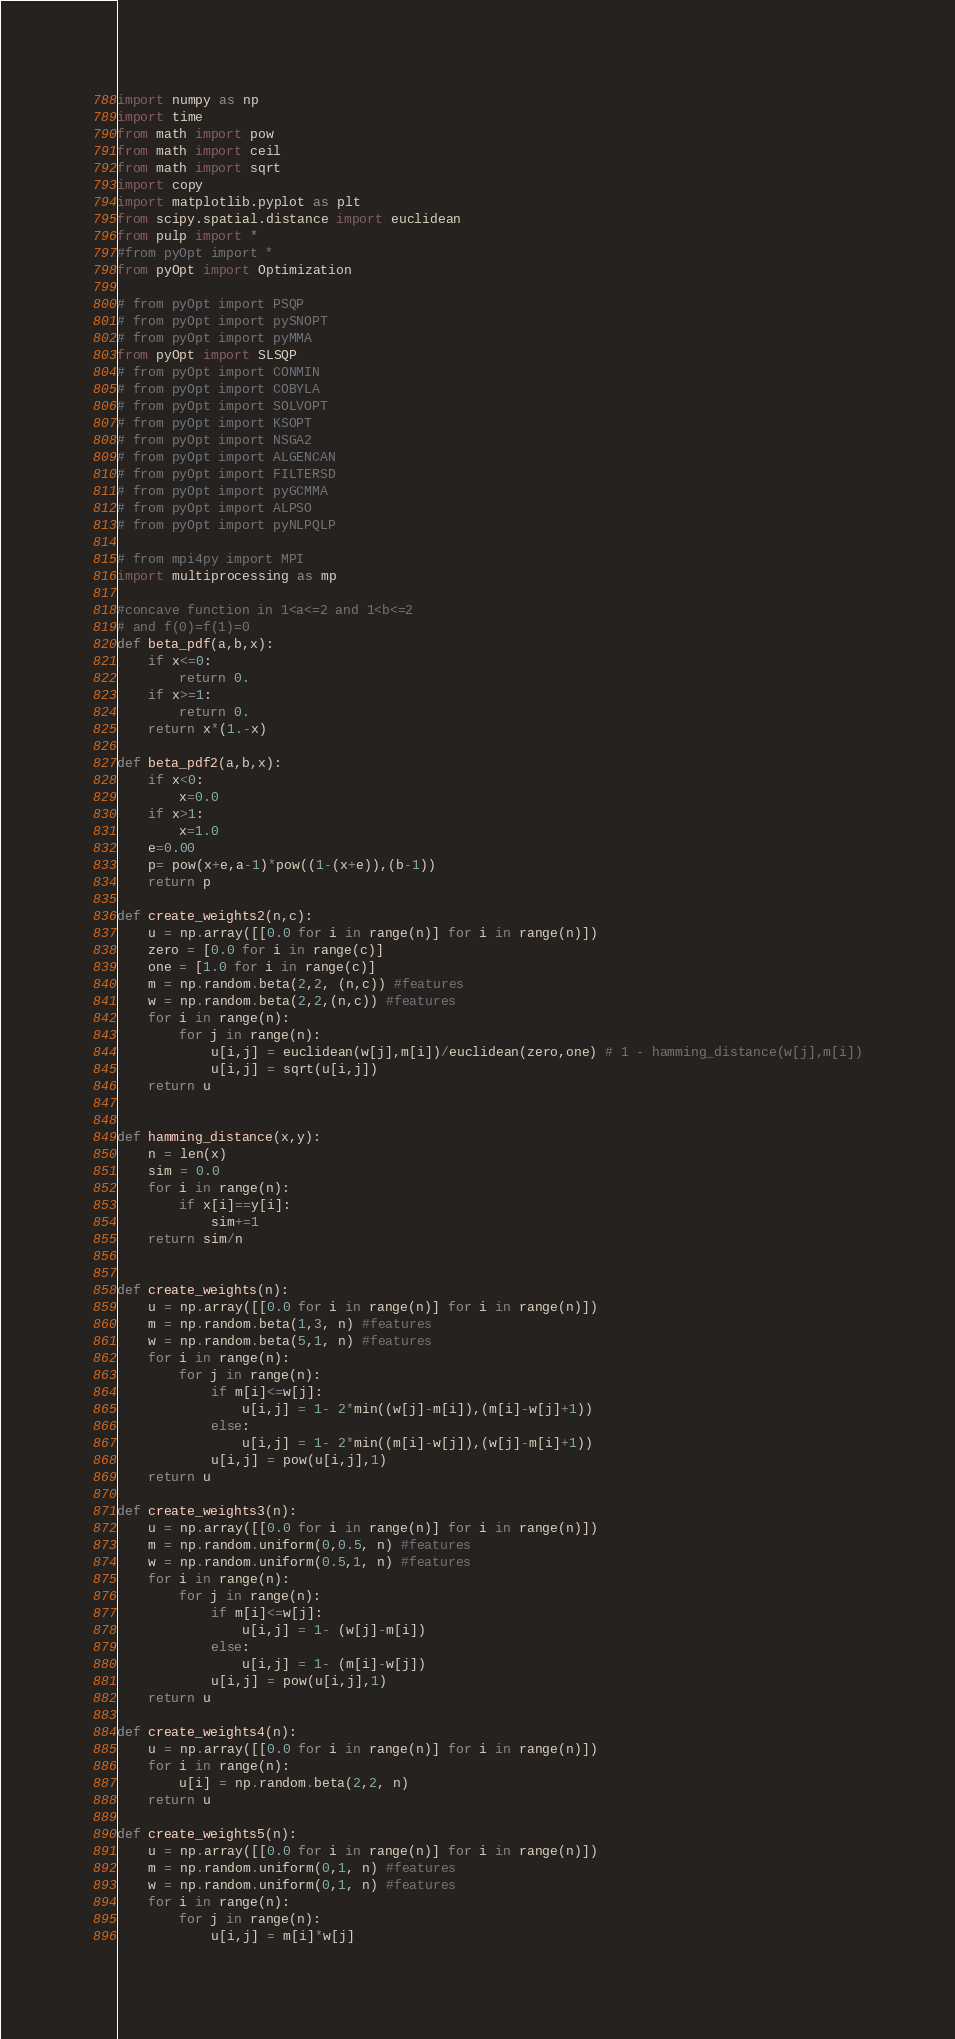Convert code to text. <code><loc_0><loc_0><loc_500><loc_500><_Python_>import numpy as np
import time
from math import pow
from math import ceil
from math import sqrt
import copy
import matplotlib.pyplot as plt
from scipy.spatial.distance import euclidean
from pulp import *
#from pyOpt import *
from pyOpt import Optimization

# from pyOpt import PSQP
# from pyOpt import pySNOPT
# from pyOpt import pyMMA
from pyOpt import SLSQP
# from pyOpt import CONMIN
# from pyOpt import COBYLA
# from pyOpt import SOLVOPT
# from pyOpt import KSOPT
# from pyOpt import NSGA2
# from pyOpt import ALGENCAN
# from pyOpt import FILTERSD
# from pyOpt import pyGCMMA
# from pyOpt import ALPSO
# from pyOpt import pyNLPQLP

# from mpi4py import MPI
import multiprocessing as mp

#concave function in 1<a<=2 and 1<b<=2
# and f(0)=f(1)=0
def beta_pdf(a,b,x):
	if x<=0:
		return 0.
	if x>=1:
		return 0.	
	return x*(1.-x)

def beta_pdf2(a,b,x):
	if x<0:
		x=0.0
	if x>1:
		x=1.0	
	e=0.00
	p= pow(x+e,a-1)*pow((1-(x+e)),(b-1))
	return p

def create_weights2(n,c):
	u = np.array([[0.0 for i in range(n)] for i in range(n)])
	zero = [0.0 for i in range(c)]
	one = [1.0 for i in range(c)]
	m = np.random.beta(2,2, (n,c)) #features
	w = np.random.beta(2,2,(n,c)) #features
	for i in range(n):
		for j in range(n):
			u[i,j] = euclidean(w[j],m[i])/euclidean(zero,one) # 1 - hamming_distance(w[j],m[i])
			u[i,j] = sqrt(u[i,j])
	return u


def hamming_distance(x,y):
	n = len(x)
	sim = 0.0
	for i in range(n):
		if x[i]==y[i]:
			sim+=1
	return sim/n


def create_weights(n):
	u = np.array([[0.0 for i in range(n)] for i in range(n)])
	m = np.random.beta(1,3, n) #features
	w = np.random.beta(5,1, n) #features
	for i in range(n):
		for j in range(n):
			if m[i]<=w[j]:
				u[i,j] = 1- 2*min((w[j]-m[i]),(m[i]-w[j]+1))
			else:
				u[i,j] = 1- 2*min((m[i]-w[j]),(w[j]-m[i]+1))
			u[i,j] = pow(u[i,j],1)
	return u

def create_weights3(n):
	u = np.array([[0.0 for i in range(n)] for i in range(n)])
	m = np.random.uniform(0,0.5, n) #features
	w = np.random.uniform(0.5,1, n) #features
	for i in range(n):
		for j in range(n):
			if m[i]<=w[j]:
				u[i,j] = 1- (w[j]-m[i])
			else:
				u[i,j] = 1- (m[i]-w[j])
			u[i,j] = pow(u[i,j],1)
	return u

def create_weights4(n):
	u = np.array([[0.0 for i in range(n)] for i in range(n)])
	for i in range(n):
		u[i] = np.random.beta(2,2, n)
	return u	

def create_weights5(n):
	u = np.array([[0.0 for i in range(n)] for i in range(n)])
	m = np.random.uniform(0,1, n) #features
	w = np.random.uniform(0,1, n) #features
	for i in range(n):
		for j in range(n):
			u[i,j] = m[i]*w[j]</code> 